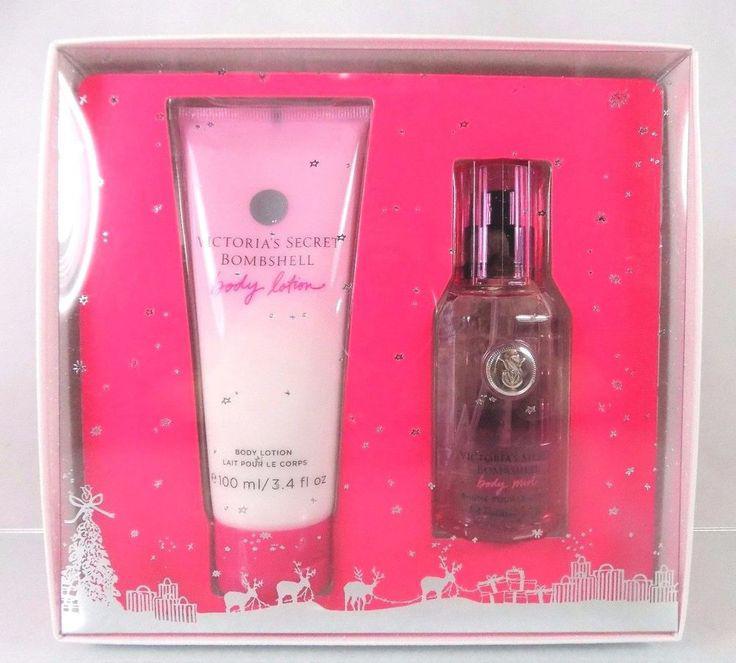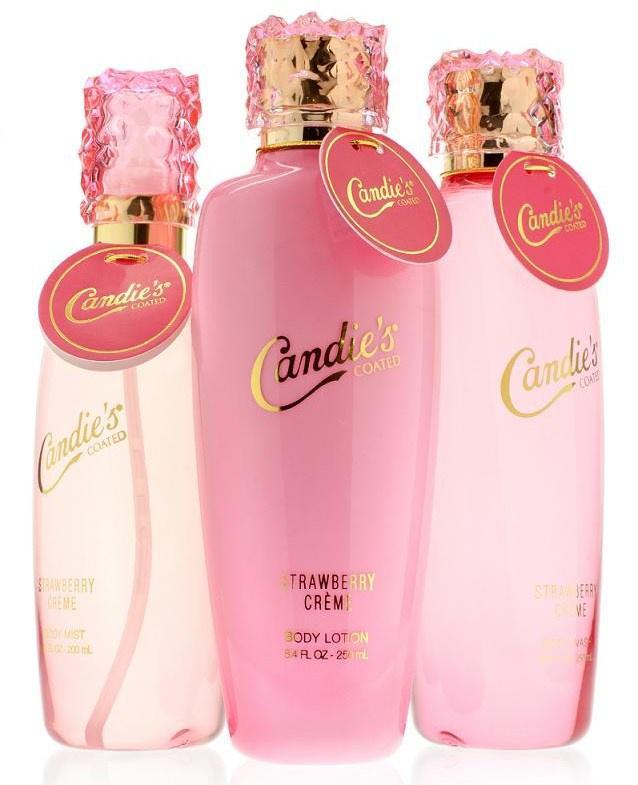The first image is the image on the left, the second image is the image on the right. Given the left and right images, does the statement "The right image contains no more than one perfume container." hold true? Answer yes or no. No. The first image is the image on the left, the second image is the image on the right. Assess this claim about the two images: "There are pink flower petals behind the container in the image on the right.". Correct or not? Answer yes or no. No. 